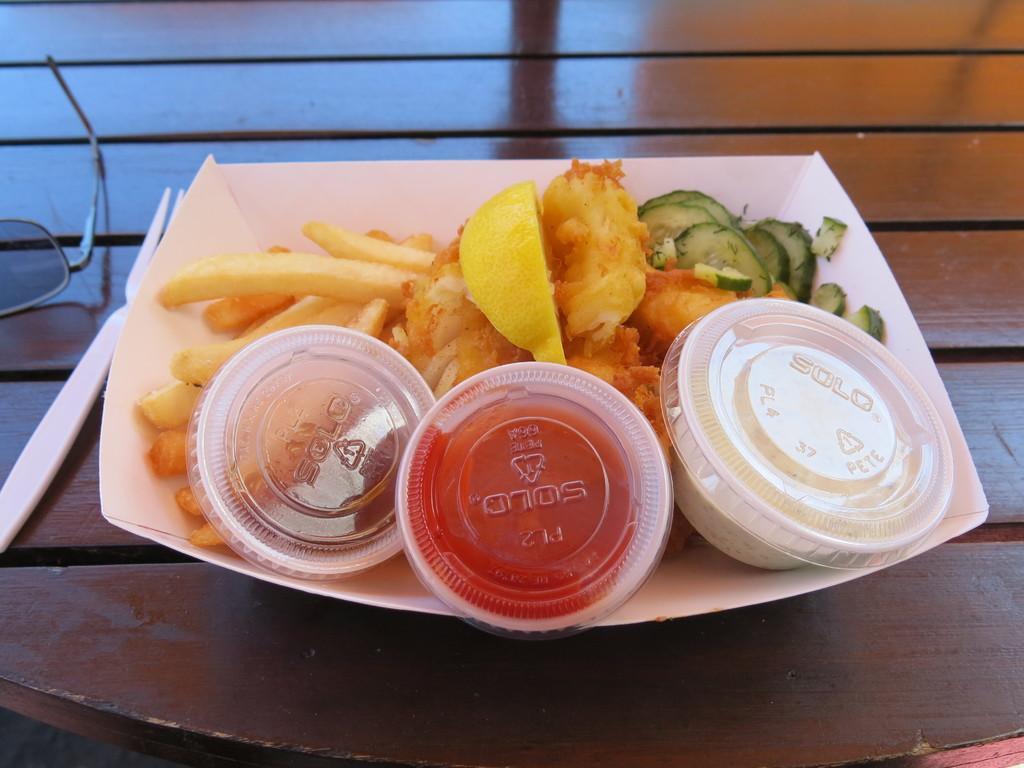Could you give a brief overview of what you see in this image? In this picture we can see a table, there is a plate, a fork and spectacles present on the table, we can see french fries, three cups and some food present in the plate. 